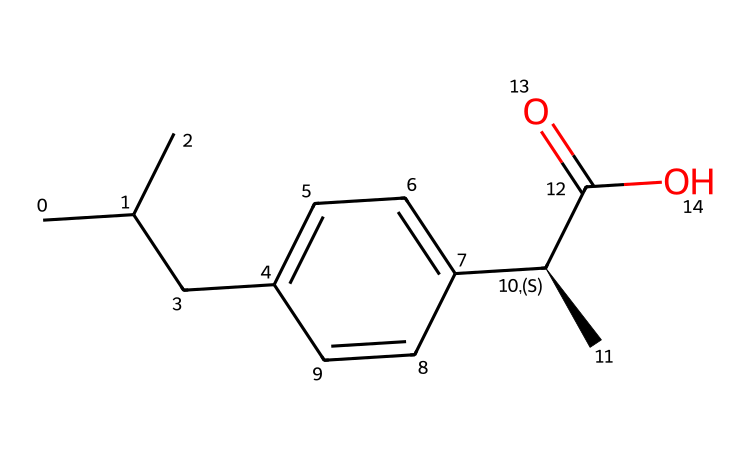What is the molecular formula of ibuprofen? The SMILES representation can be analyzed to count the number of each type of atom. From the formula provided, we can deduce that there are 13 carbons (C), 18 hydrogens (H), and 2 oxygens (O). Therefore, the molecular formula is C13H18O2.
Answer: C13H18O2 How many chiral centers are present in ibuprofen? Chiral centers are indicated by atoms bonded to four different substituents. In the provided SMILES, the [C@H] signifies a chiral carbon, indicating there is one chiral center in ibuprofen.
Answer: one What type of functional group is present in ibuprofen? The SMILES shows a carboxylic acid functional group (-COOH) at the end of the molecule. The presence of the “C(=O)O” part in the SMILES confirms this.
Answer: carboxylic acid What is the total number of double bonds in ibuprofen? In the structure, a double bond exists between the carbon and oxygen atoms in the carboxylic acid group, which is part of the structure. There are no other double bonds present in the structure. Therefore, counting the one existing double bond provides the answer.
Answer: one What is the primary use of ibuprofen? Ibuprofen is widely recognized as a non-steroidal anti-inflammatory drug (NSAID) used primarily to relieve pain, reduce inflammation, and lower fever. It is commonly used for conditions like arthritis or, in this case, computer-related repetitive strain injuries.
Answer: pain relief 